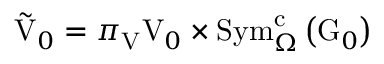<formula> <loc_0><loc_0><loc_500><loc_500>\tilde { V } _ { 0 } = \pi _ { V } V _ { 0 } \times S y m _ { \Omega } ^ { c } \left ( G _ { 0 } \right )</formula> 